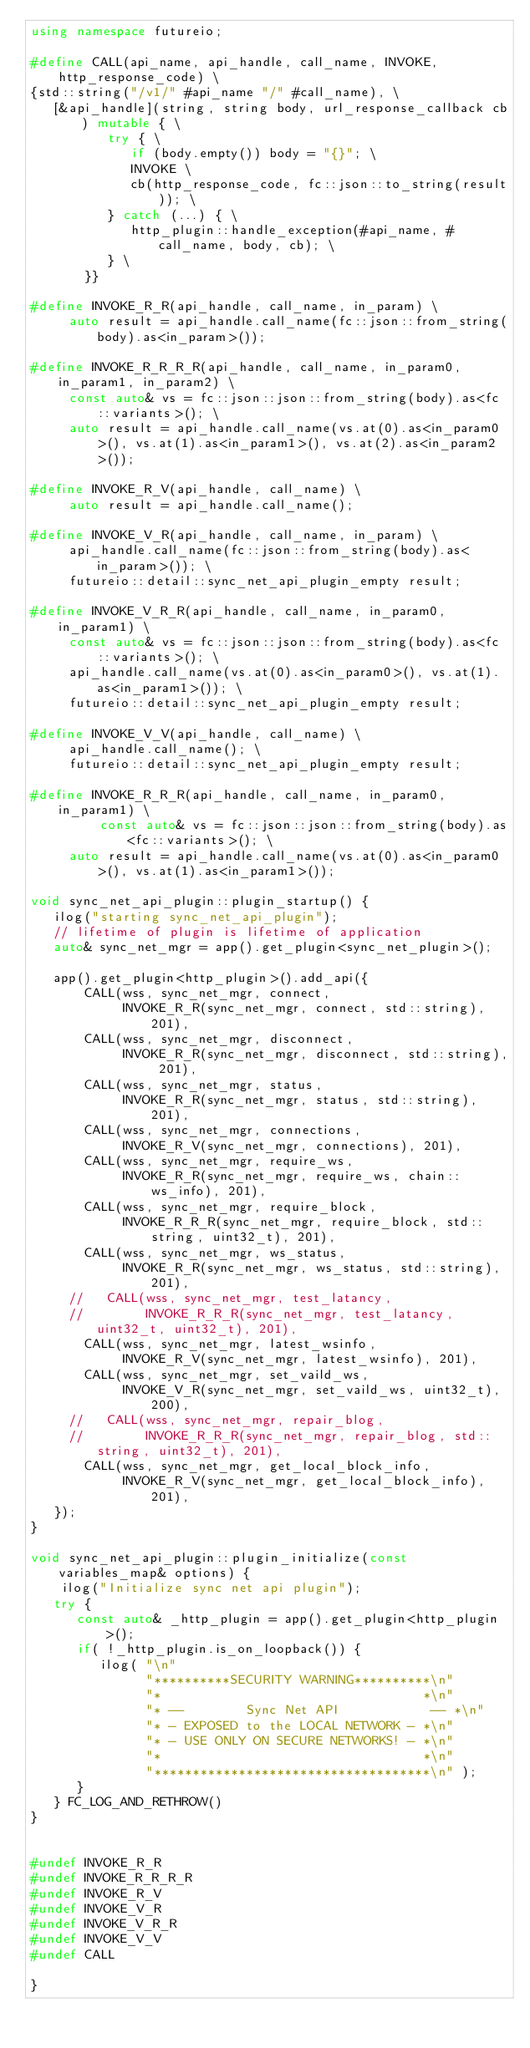Convert code to text. <code><loc_0><loc_0><loc_500><loc_500><_C++_>using namespace futureio;

#define CALL(api_name, api_handle, call_name, INVOKE, http_response_code) \
{std::string("/v1/" #api_name "/" #call_name), \
   [&api_handle](string, string body, url_response_callback cb) mutable { \
          try { \
             if (body.empty()) body = "{}"; \
             INVOKE \
             cb(http_response_code, fc::json::to_string(result)); \
          } catch (...) { \
             http_plugin::handle_exception(#api_name, #call_name, body, cb); \
          } \
       }}

#define INVOKE_R_R(api_handle, call_name, in_param) \
     auto result = api_handle.call_name(fc::json::from_string(body).as<in_param>());

#define INVOKE_R_R_R_R(api_handle, call_name, in_param0, in_param1, in_param2) \
     const auto& vs = fc::json::json::from_string(body).as<fc::variants>(); \
     auto result = api_handle.call_name(vs.at(0).as<in_param0>(), vs.at(1).as<in_param1>(), vs.at(2).as<in_param2>());

#define INVOKE_R_V(api_handle, call_name) \
     auto result = api_handle.call_name();

#define INVOKE_V_R(api_handle, call_name, in_param) \
     api_handle.call_name(fc::json::from_string(body).as<in_param>()); \
     futureio::detail::sync_net_api_plugin_empty result;

#define INVOKE_V_R_R(api_handle, call_name, in_param0, in_param1) \
     const auto& vs = fc::json::json::from_string(body).as<fc::variants>(); \
     api_handle.call_name(vs.at(0).as<in_param0>(), vs.at(1).as<in_param1>()); \
     futureio::detail::sync_net_api_plugin_empty result;

#define INVOKE_V_V(api_handle, call_name) \
     api_handle.call_name(); \
     futureio::detail::sync_net_api_plugin_empty result;

#define INVOKE_R_R_R(api_handle, call_name, in_param0, in_param1) \
         const auto& vs = fc::json::json::from_string(body).as<fc::variants>(); \
     auto result = api_handle.call_name(vs.at(0).as<in_param0>(), vs.at(1).as<in_param1>());

void sync_net_api_plugin::plugin_startup() {
   ilog("starting sync_net_api_plugin");
   // lifetime of plugin is lifetime of application
   auto& sync_net_mgr = app().get_plugin<sync_net_plugin>();

   app().get_plugin<http_plugin>().add_api({
       CALL(wss, sync_net_mgr, connect,
            INVOKE_R_R(sync_net_mgr, connect, std::string), 201),
       CALL(wss, sync_net_mgr, disconnect,
            INVOKE_R_R(sync_net_mgr, disconnect, std::string), 201),
       CALL(wss, sync_net_mgr, status,
            INVOKE_R_R(sync_net_mgr, status, std::string), 201),
       CALL(wss, sync_net_mgr, connections,
            INVOKE_R_V(sync_net_mgr, connections), 201),
       CALL(wss, sync_net_mgr, require_ws,
            INVOKE_R_R(sync_net_mgr, require_ws, chain::ws_info), 201),
       CALL(wss, sync_net_mgr, require_block,
            INVOKE_R_R_R(sync_net_mgr, require_block, std::string, uint32_t), 201),
       CALL(wss, sync_net_mgr, ws_status,
            INVOKE_R_R(sync_net_mgr, ws_status, std::string), 201),
     //   CALL(wss, sync_net_mgr, test_latancy,
     //        INVOKE_R_R_R(sync_net_mgr, test_latancy, uint32_t, uint32_t), 201),
       CALL(wss, sync_net_mgr, latest_wsinfo,
            INVOKE_R_V(sync_net_mgr, latest_wsinfo), 201),
       CALL(wss, sync_net_mgr, set_vaild_ws,
            INVOKE_V_R(sync_net_mgr, set_vaild_ws, uint32_t), 200),
     //   CALL(wss, sync_net_mgr, repair_blog,
     //        INVOKE_R_R_R(sync_net_mgr, repair_blog, std::string, uint32_t), 201),
       CALL(wss, sync_net_mgr, get_local_block_info,
            INVOKE_R_V(sync_net_mgr, get_local_block_info), 201),
   });
}

void sync_net_api_plugin::plugin_initialize(const variables_map& options) {
    ilog("Initialize sync net api plugin");
   try {
      const auto& _http_plugin = app().get_plugin<http_plugin>();
      if( !_http_plugin.is_on_loopback()) {
         ilog( "\n"
               "**********SECURITY WARNING**********\n"
               "*                                  *\n"
               "* --        Sync Net API            -- *\n"
               "* - EXPOSED to the LOCAL NETWORK - *\n"
               "* - USE ONLY ON SECURE NETWORKS! - *\n"
               "*                                  *\n"
               "************************************\n" );
      }
   } FC_LOG_AND_RETHROW()
}


#undef INVOKE_R_R
#undef INVOKE_R_R_R_R
#undef INVOKE_R_V
#undef INVOKE_V_R
#undef INVOKE_V_R_R
#undef INVOKE_V_V
#undef CALL

}
</code> 